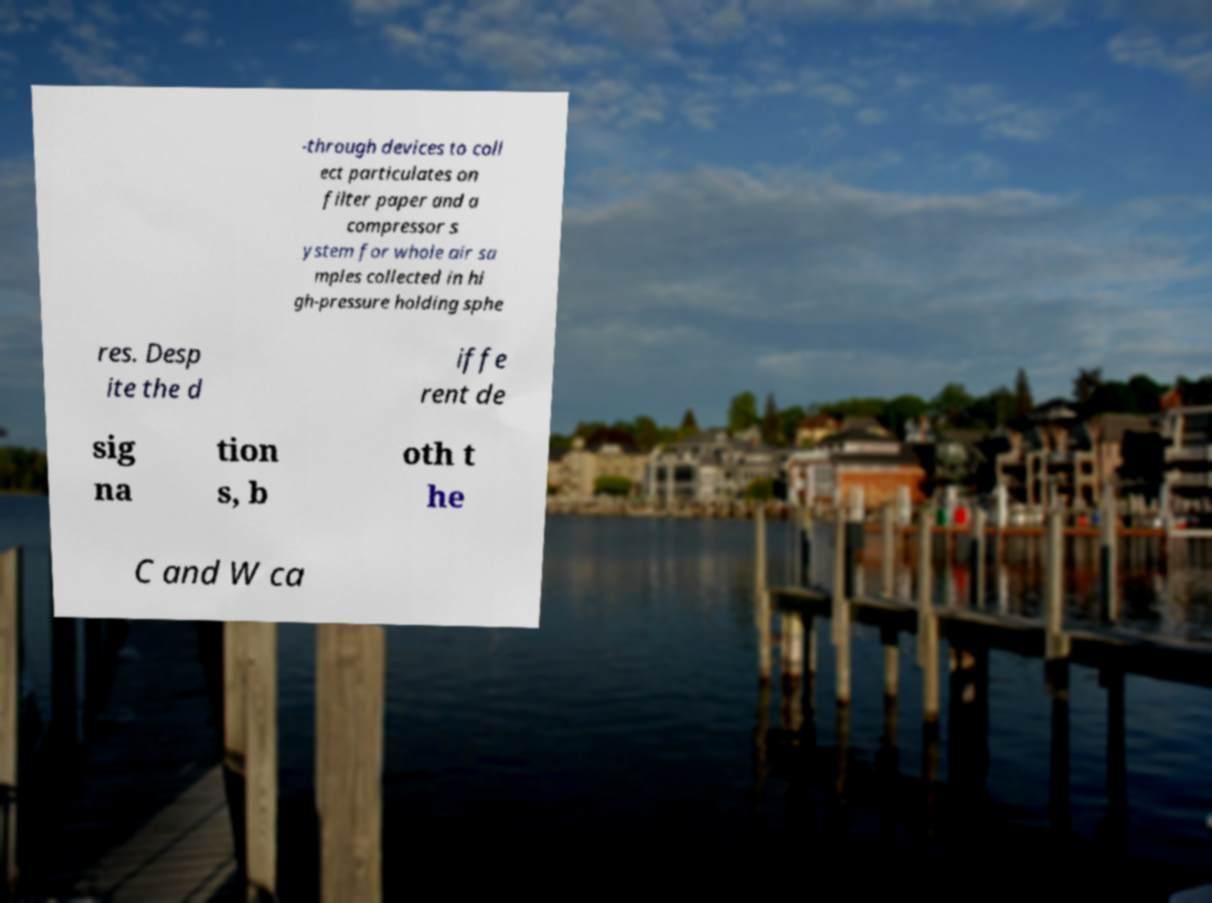Could you extract and type out the text from this image? -through devices to coll ect particulates on filter paper and a compressor s ystem for whole air sa mples collected in hi gh-pressure holding sphe res. Desp ite the d iffe rent de sig na tion s, b oth t he C and W ca 